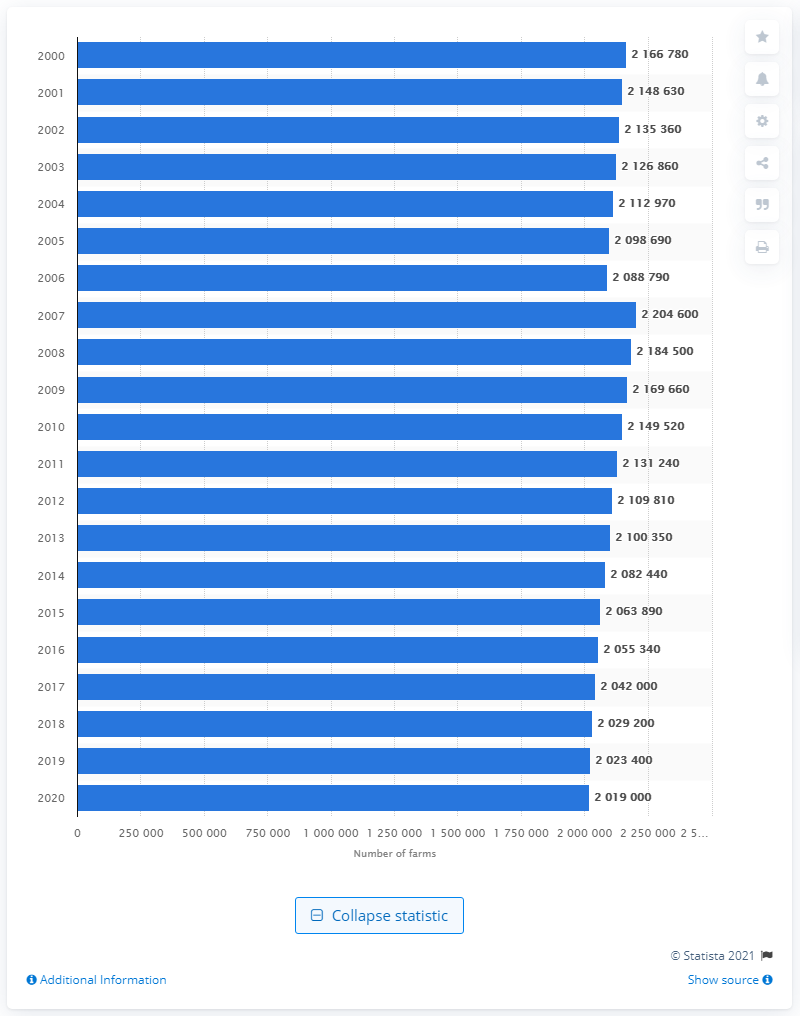Specify some key components in this picture. In 2007, there were approximately 220,4600 farms in the United States. 